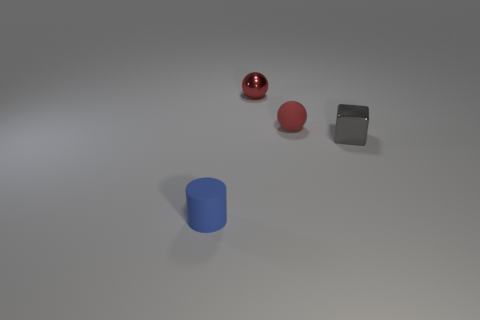Add 3 large yellow metal blocks. How many objects exist? 7 Subtract all blocks. How many objects are left? 3 Add 3 small spheres. How many small spheres exist? 5 Subtract 0 purple balls. How many objects are left? 4 Subtract all tiny gray blocks. Subtract all tiny rubber cylinders. How many objects are left? 2 Add 1 rubber objects. How many rubber objects are left? 3 